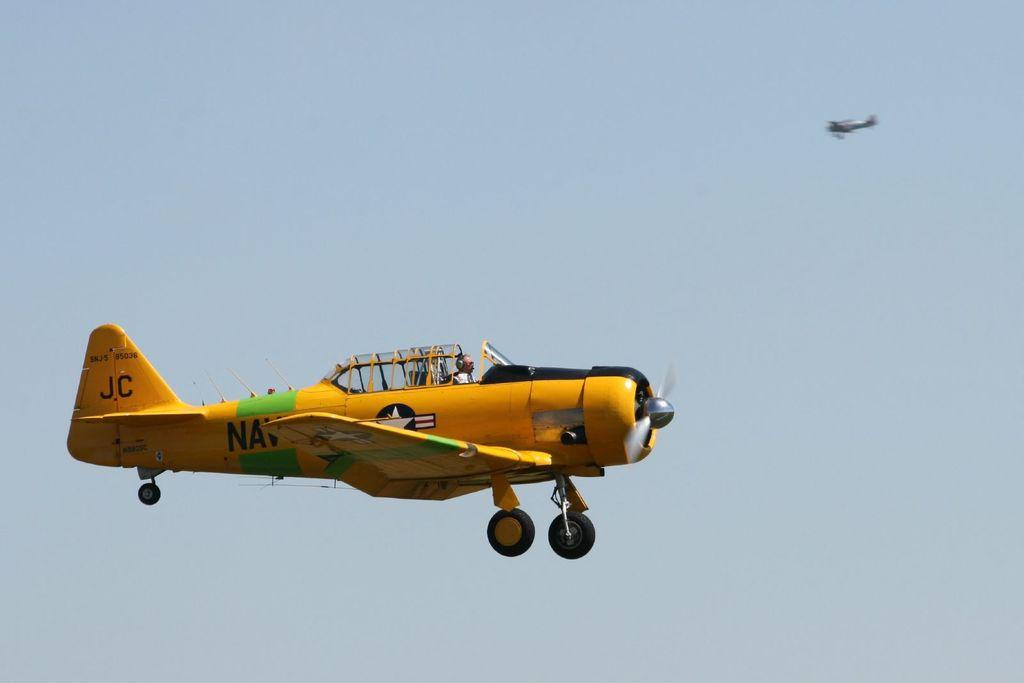<image>
Offer a succinct explanation of the picture presented. A man flies a yellow plain with JC painted on the rear rudder. 